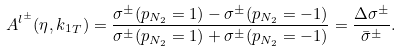<formula> <loc_0><loc_0><loc_500><loc_500>A ^ { l ^ { \pm } } ( \eta , { k _ { 1 } } _ { T } ) = \frac { \sigma ^ { \pm } ( p _ { N _ { 2 } } = 1 ) - \sigma ^ { \pm } ( p _ { N _ { 2 } } = - 1 ) } { \sigma ^ { \pm } ( p _ { N _ { 2 } } = 1 ) + \sigma ^ { \pm } ( p _ { N _ { 2 } } = - 1 ) } = \frac { \Delta \sigma ^ { \pm } } { \bar { \sigma } ^ { \pm } } .</formula> 